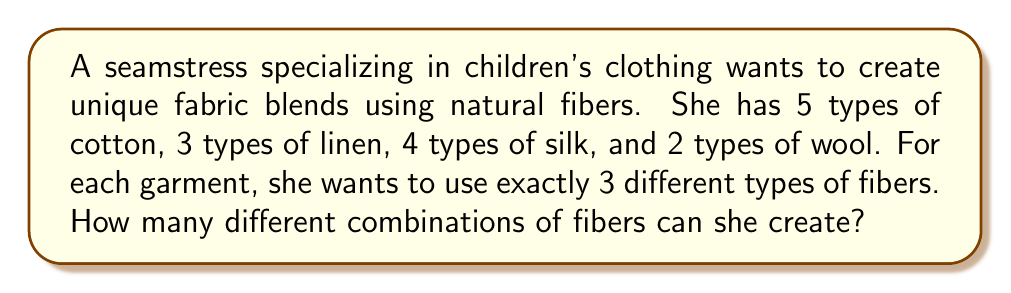Show me your answer to this math problem. Let's approach this step-by-step:

1) This is a combination problem where order doesn't matter (choosing cotton, linen, and silk is the same as choosing linen, silk, and cotton).

2) We need to choose 3 different types of fibers from the 4 available categories (cotton, linen, silk, and wool).

3) We can use the combination formula to calculate this:

   $$\binom{4}{3} = \frac{4!}{3!(4-3)!} = \frac{4 \cdot 3 \cdot 2 \cdot 1}{(3 \cdot 2 \cdot 1)(1)} = 4$$

4) Now, for each of these 4 combinations of fiber categories, we need to choose one specific type from each category.

5) Let's consider each possible combination:
   - Cotton, Linen, Silk: $5 \cdot 3 \cdot 4 = 60$ combinations
   - Cotton, Linen, Wool: $5 \cdot 3 \cdot 2 = 30$ combinations
   - Cotton, Silk, Wool: $5 \cdot 4 \cdot 2 = 40$ combinations
   - Linen, Silk, Wool: $3 \cdot 4 \cdot 2 = 24$ combinations

6) The total number of combinations is the sum of all these possibilities:

   $$60 + 30 + 40 + 24 = 154$$

Therefore, the seamstress can create 154 different combinations of fibers.
Answer: 154 